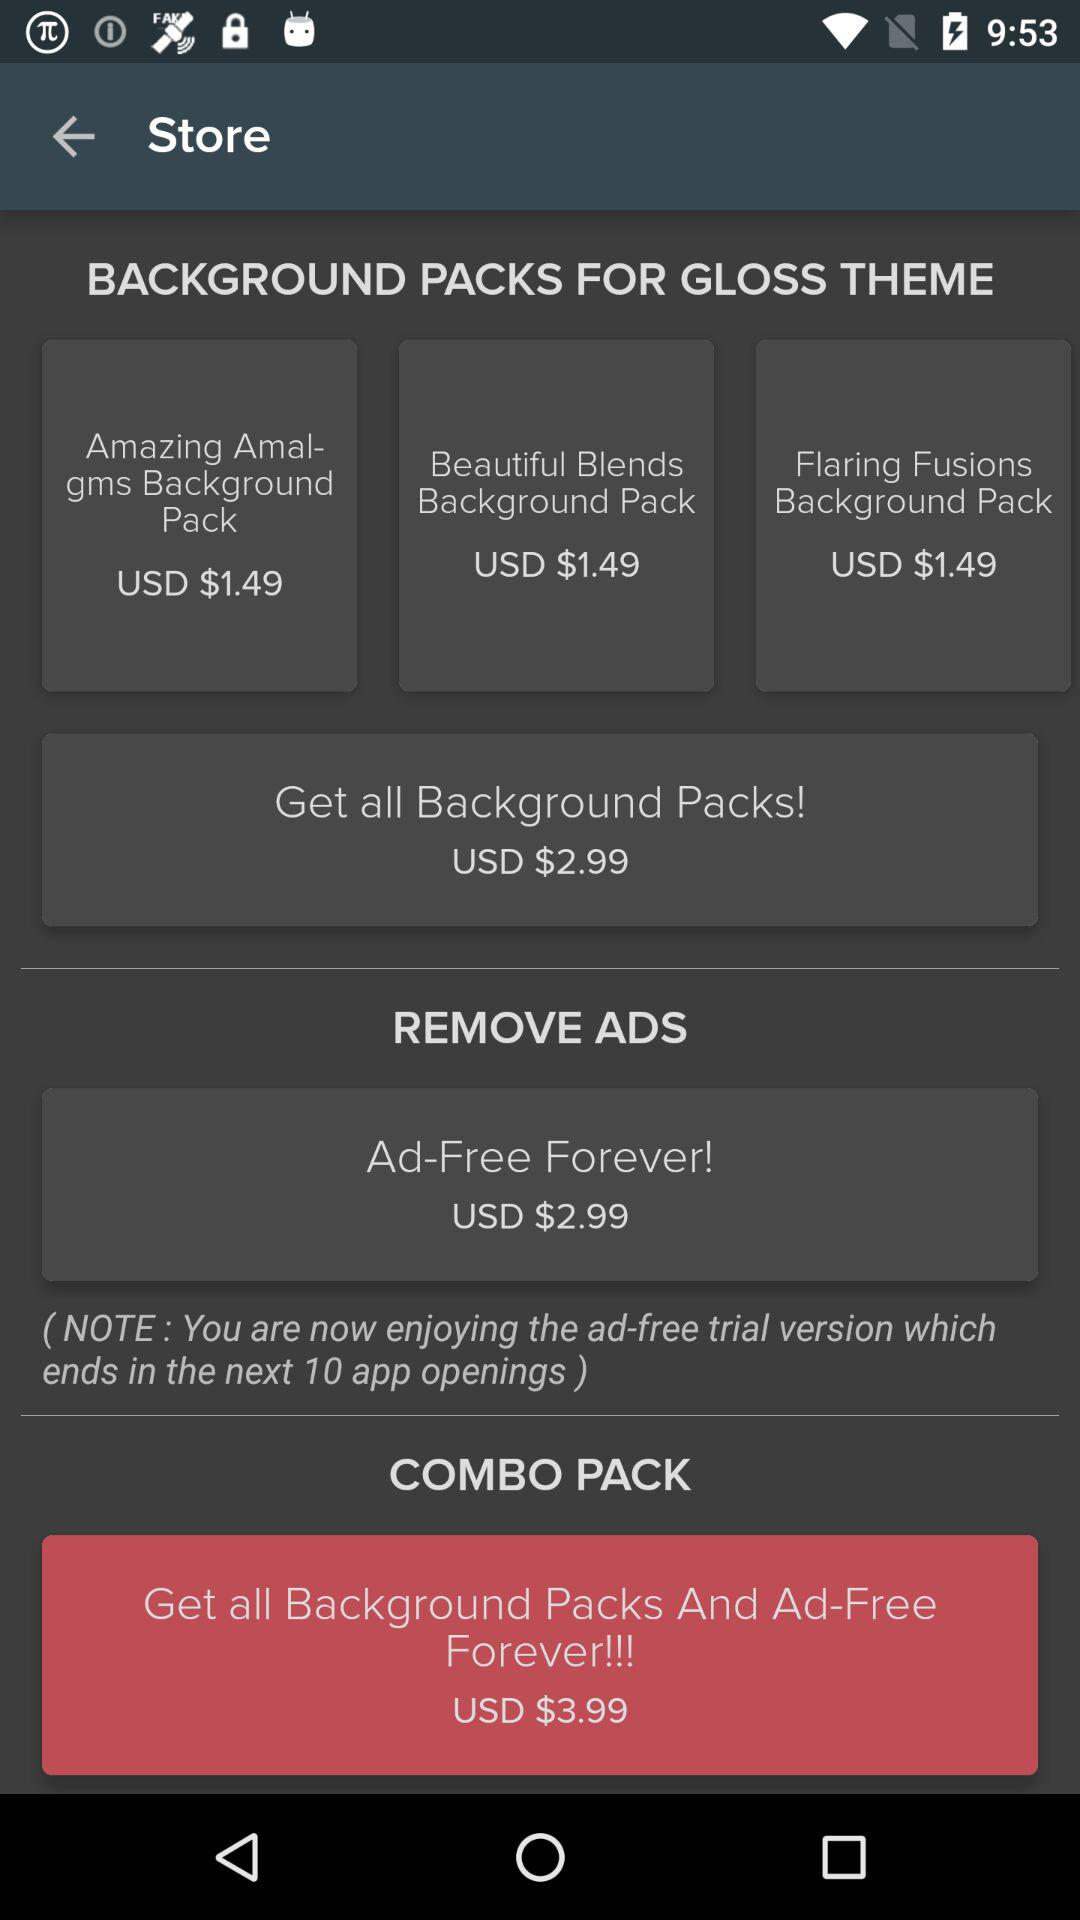How many of the items are priced at $1.49?
Answer the question using a single word or phrase. 3 